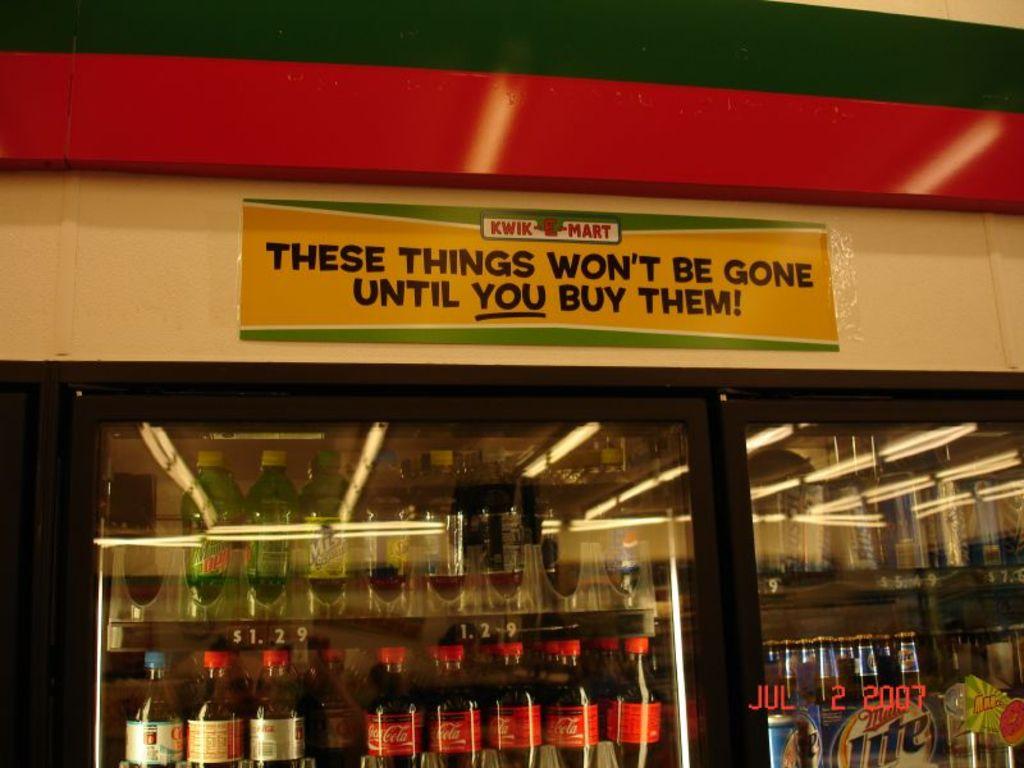What convenience store is this?
Make the answer very short. Kwik mart. What is the quote saying above the drinks?
Your response must be concise. These things won't be gone until you buy them!. 